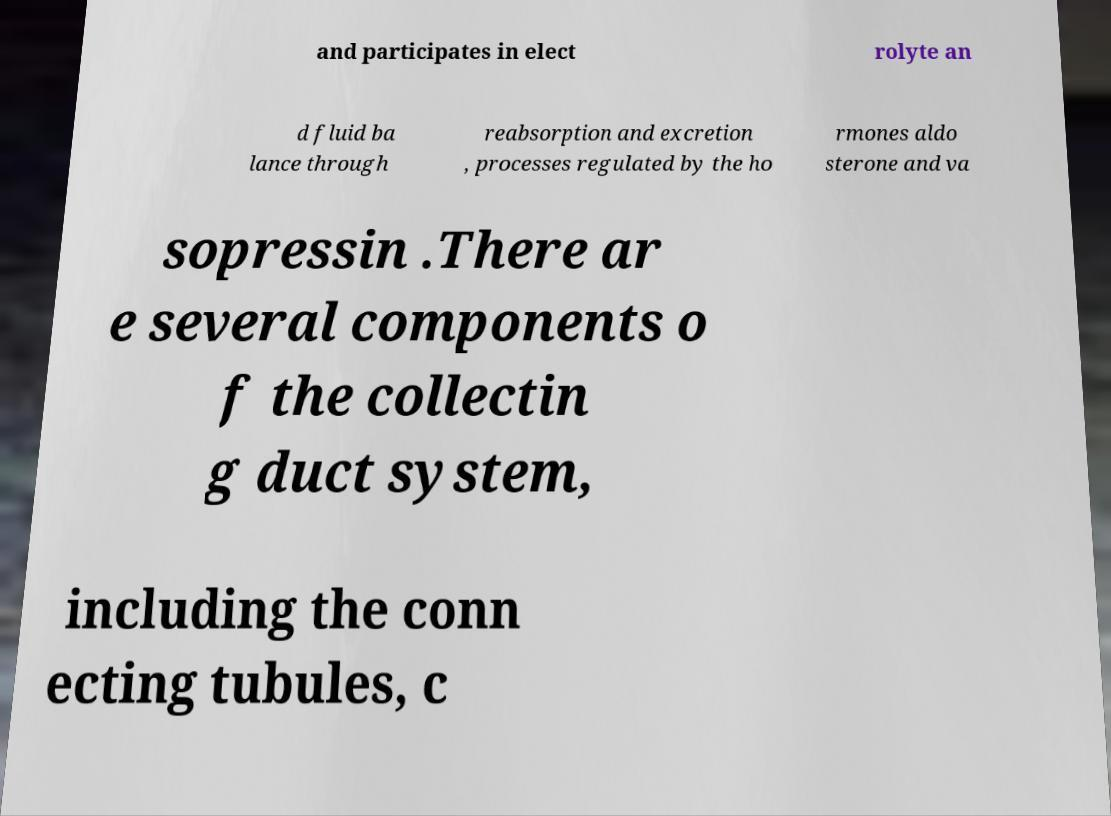Can you accurately transcribe the text from the provided image for me? and participates in elect rolyte an d fluid ba lance through reabsorption and excretion , processes regulated by the ho rmones aldo sterone and va sopressin .There ar e several components o f the collectin g duct system, including the conn ecting tubules, c 